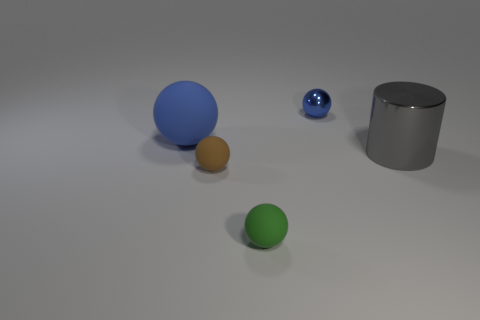Add 3 spheres. How many objects exist? 8 Subtract all balls. How many objects are left? 1 Subtract 0 green blocks. How many objects are left? 5 Subtract all blue rubber balls. Subtract all gray cylinders. How many objects are left? 3 Add 1 blue metal balls. How many blue metal balls are left? 2 Add 2 big cylinders. How many big cylinders exist? 3 